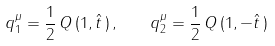Convert formula to latex. <formula><loc_0><loc_0><loc_500><loc_500>q _ { 1 } ^ { \mu } = \frac { 1 } { 2 } \, Q \, ( 1 , \hat { t } \, ) \, , \quad q _ { 2 } ^ { \mu } = \frac { 1 } { 2 } \, Q \, ( 1 , - \hat { t } \, )</formula> 